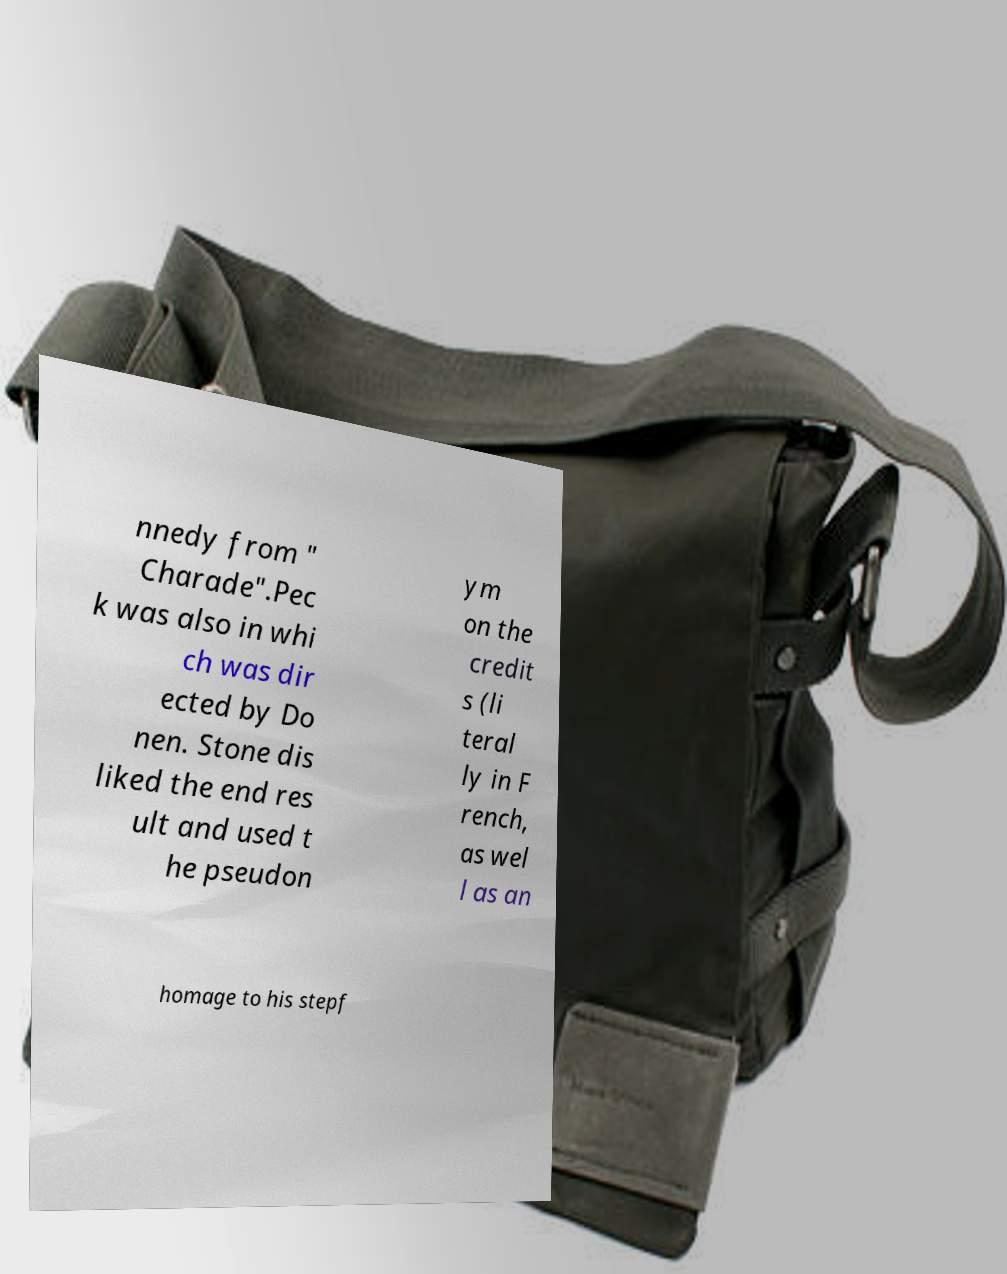Could you extract and type out the text from this image? nnedy from " Charade".Pec k was also in whi ch was dir ected by Do nen. Stone dis liked the end res ult and used t he pseudon ym on the credit s (li teral ly in F rench, as wel l as an homage to his stepf 